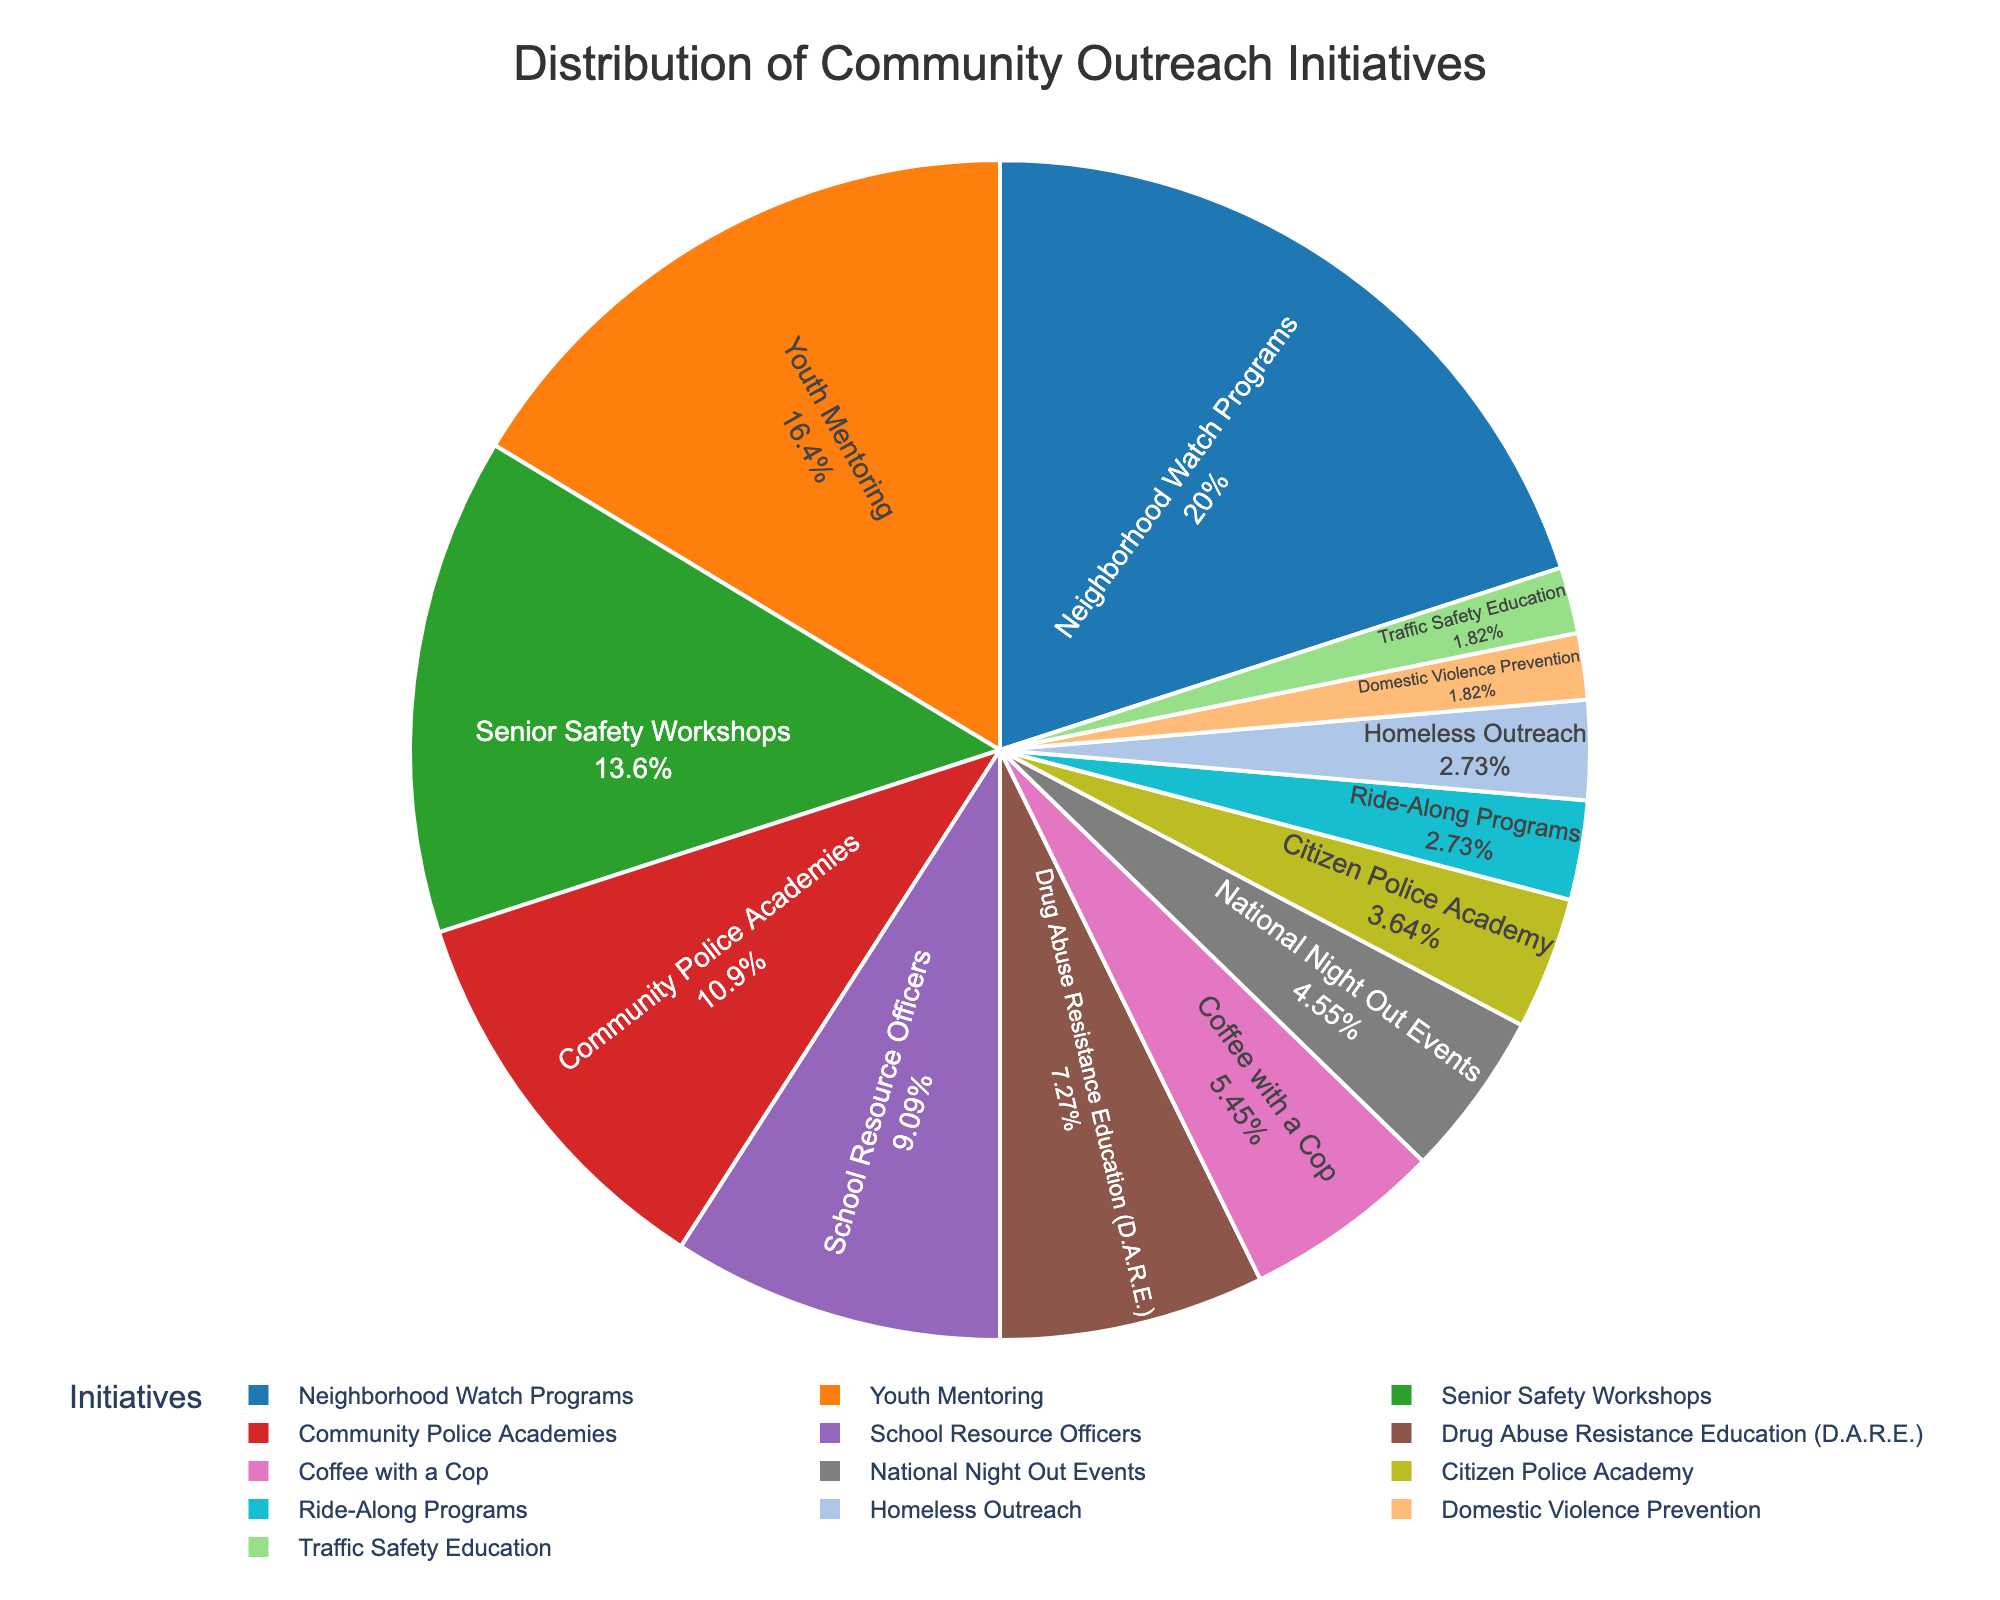What is the largest initiative by percentage? The largest slice in the pie chart represents Neighborhood Watch Programs. By looking at the size and labels of the slices, it is clear that Neighborhood Watch Programs have the highest percentage.
Answer: Neighborhood Watch Programs Which initiative has a smaller percentage, Youth Mentoring or School Resource Officers? Comparing the slices of the pie chart labeled Youth Mentoring and School Resource Officers, Youth Mentoring is 18% and School Resource Officers is 10%.
Answer: School Resource Officers How much more percentage does Neighborhood Watch Programs have compared to Coffee with a Cop? The slice for Neighborhood Watch Programs is 22% and the slice for Coffee with a Cop is 6%. Subtract 6 from 22 to find the difference.
Answer: 16% What is the total percentage for the initiatives that are below 10%? Add the percentages of School Resource Officers (10%), D.A.R.E. (8%), Coffee with a Cop (6%), National Night Out Events (5%), Citizen Police Academy (4%), Ride-Along Programs (3%), Homeless Outreach (3%), Domestic Violence Prevention (2%), and Traffic Safety Education (2%). The sum is 43%.
Answer: 43% Which initiatives have equal percentages? By checking the labels, Ride-Along Programs and Homeless Outreach both have slices labeled as 3%, and Domestic Violence Prevention and Traffic Safety Education both have slices labeled as 2%.
Answer: Ride-Along Programs & Homeless Outreach, Domestic Violence Prevention & Traffic Safety Education What is the combined percentage of the Community Police Academies and Senior Safety Workshops? The slices for Community Police Academies and Senior Safety Workshops are 12% and 15%, respectively. Add 12 and 15 to get the combined percentage.
Answer: 27% Compare the percentage of Drug Abuse Resistance Education (D.A.R.E.) to the combined percentage of National Night Out Events and Ride-Along Programs. Which is greater? The percentage for D.A.R.E. is 8%. Adding National Night Out Events (5%) and Ride-Along Programs (3%) gives 8%. Since both are equal, neither is greater.
Answer: Equal Is the combined percentage of Youth Mentoring and School Resource Officers higher than that of Neighborhood Watch Programs? The slices for Youth Mentoring and School Resource Officers are 18% and 10%, respectively, totaling 28%. Comparing to the Neighborhood Watch Programs slice, which is 22%, 28% is higher.
Answer: Yes Which initiatives use different colors but have equal percentages? By observing the colors and labels, Ride-Along Programs and Homeless Outreach use different colors but both have slices labeled as 3%.
Answer: Ride-Along Programs & Homeless Outreach 